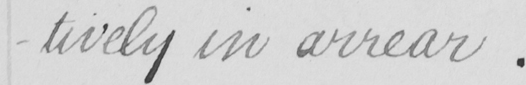Can you read and transcribe this handwriting? -tively in arrear . 